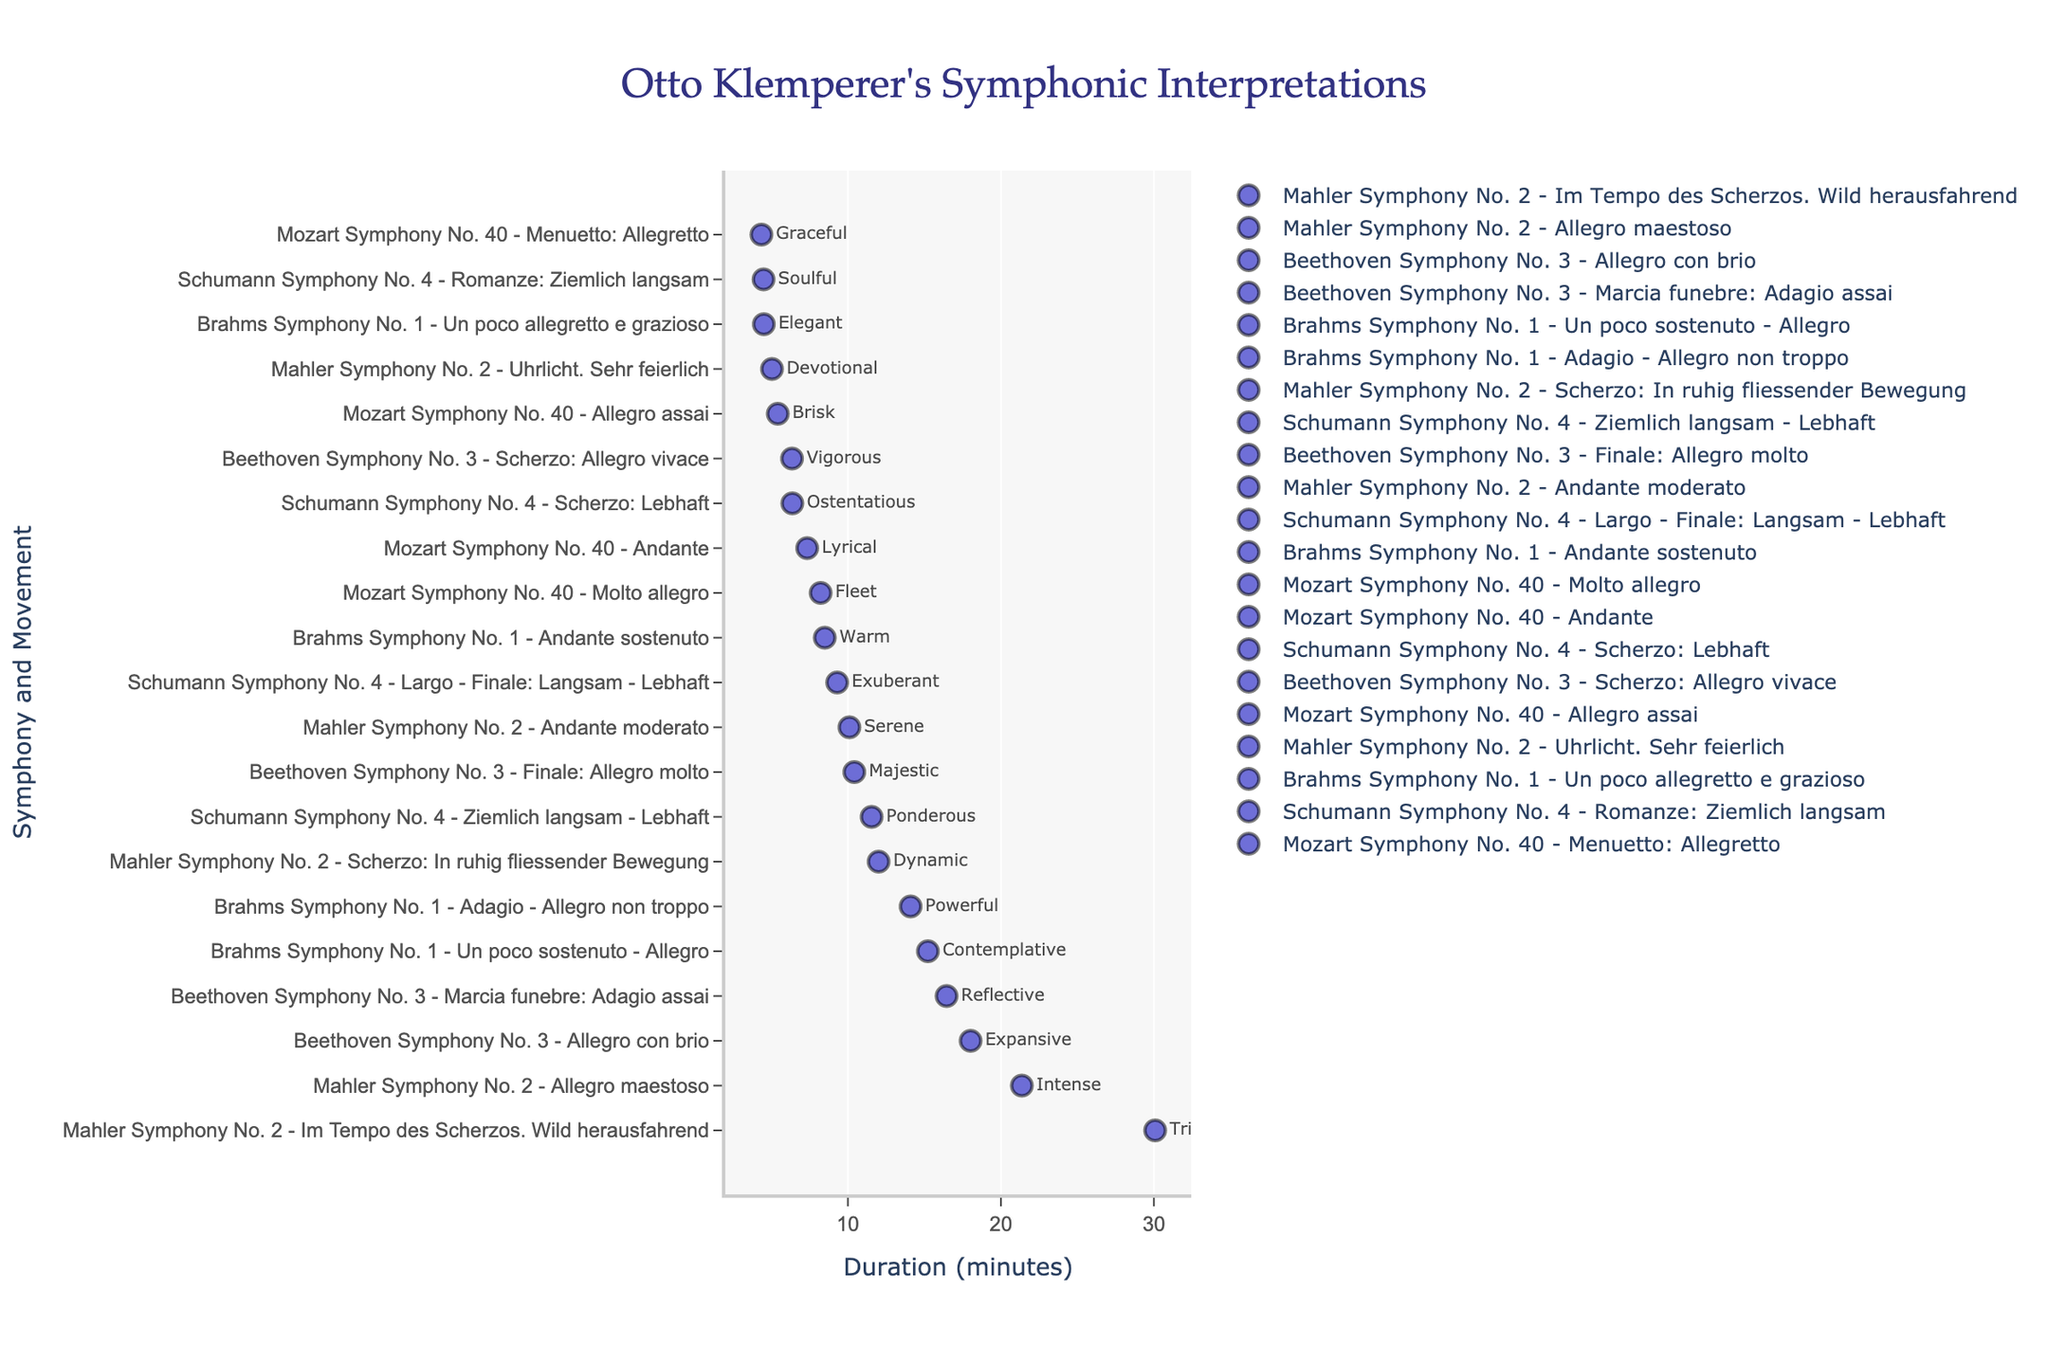What's the longest movement duration recorded by Otto Klemperer according to the plot? Find the marker at the farthest right on the x-axis, which corresponds to the longest duration. This is the "Im Tempo des Scherzos. Wild herausfahrend" from Mahler Symphony No. 2, with a duration of 30.08 minutes.
Answer: 30.08 minutes What symphony and movement have the shortest duration, and what is its interpretation? Look for the marker at the farthest left on the x-axis, which corresponds to the shortest duration. This is the "Menuetto: Allegretto" from Mozart Symphony No. 40, with an interpretation of "Graceful" and a duration of 4.35 minutes.
Answer: Mozart Symphony No. 40, Menuetto: Allegretto, Graceful How many movements in total are represented in the figure? Count the unique markers for each symphony and movement. From the dataset, there are 21 movements represented.
Answer: 21 Which symphony has the movement labeled as "Powerful," and what is its duration? Search for the "Powerful" interpretation label in the figure. It belongs to Brahms Symphony No. 1, "Adagio - Allegro non troppo," with a duration of 14.10 minutes.
Answer: Brahms Symphony No. 1, 14.10 minutes Compare the durations of the longest and shortest movements in Beethoven Symphony No. 3. What is the difference? Identify the longest and shortest durations for movements in Beethoven Symphony No. 3. The longest is "Allegro con brio" at 18.02 minutes and the shortest is "Scherzo: Allegro vivace" at 6.35 minutes. Subtract the shortest from the longest: 18.02 - 6.35 = 11.67 minutes.
Answer: 11.67 minutes What is the average duration of movements in Schumann Symphony No. 4? Sum the durations of all movements in Schumann Symphony No. 4 (11.55, 4.49, 6.37, 9.30) and divide by the number of movements (4). (11.55 + 4.49 + 6.37 + 9.30) / 4 = 7.428 minutes.
Answer: 7.43 minutes Among the symphonies, which one has the most varied durations of its movements? Compare the range of durations (difference between the longest and shortest duration) for each symphony. Mahler Symphony No. 2 has the most varied durations with the difference between 30.08 minutes (longest) and 5.04 minutes (shortest).
Answer: Mahler Symphony No. 2 Which movement is considered "Triumphant," and how does its duration compare to the "Intense" movement in the same symphony? "Triumphant" is found under Mahler Symphony No. 2, "Im Tempo des Scherzos. Wild herausfahrend" with a duration of 30.08 minutes. "Intense" is the "Allegro maestoso" in the same symphony with a duration of 21.37 minutes. Subtract 21.37 from 30.08: 30.08 - 21.37 = 8.71 minutes longer.
Answer: 8.71 minutes longer Which interpretation, "Fleet" or "Lyrical," represents a longer duration in Mozart Symphony No. 40? Compare the durations of the movements labeled as "Fleet" (8.22 minutes) and "Lyrical" (7.34 minutes) in Mozart Symphony No. 40. "Fleet" represents a longer duration.
Answer: Fleet Is the average duration of Beethoven Symphony No. 3's movements greater than that of Brahms Symphony No. 1's movements? Calculate the average duration of the movements in Beethoven Symphony No. 3: (18.02 + 16.45 + 6.35 + 10.42) / 4 = 12.81 minutes. For Brahms Symphony No. 1: (15.23 + 8.49 + 4.51 + 14.10) / 4 = 10.58 minutes. Compare 12.81 and 10.58.
Answer: Yes, greater 